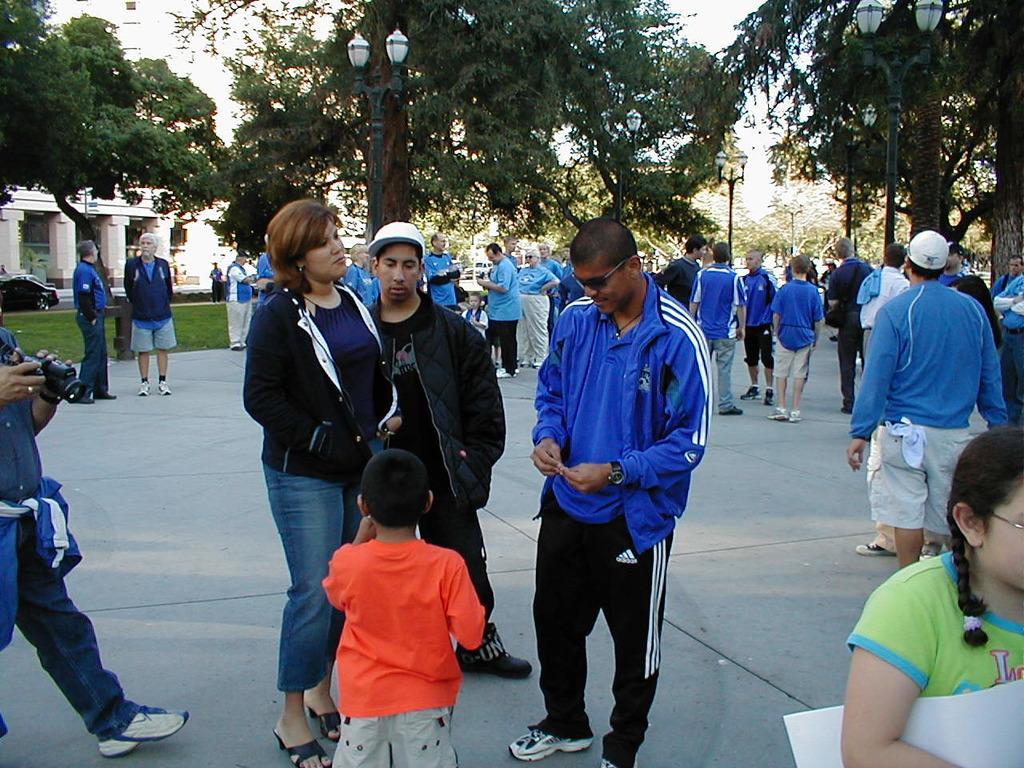How would you summarize this image in a sentence or two? In this picture we can see group of people, few are standing and few are walking, in the background we can see few poles, lights, trees and cars, on the left side of the image we can see a person is holding a camera. 